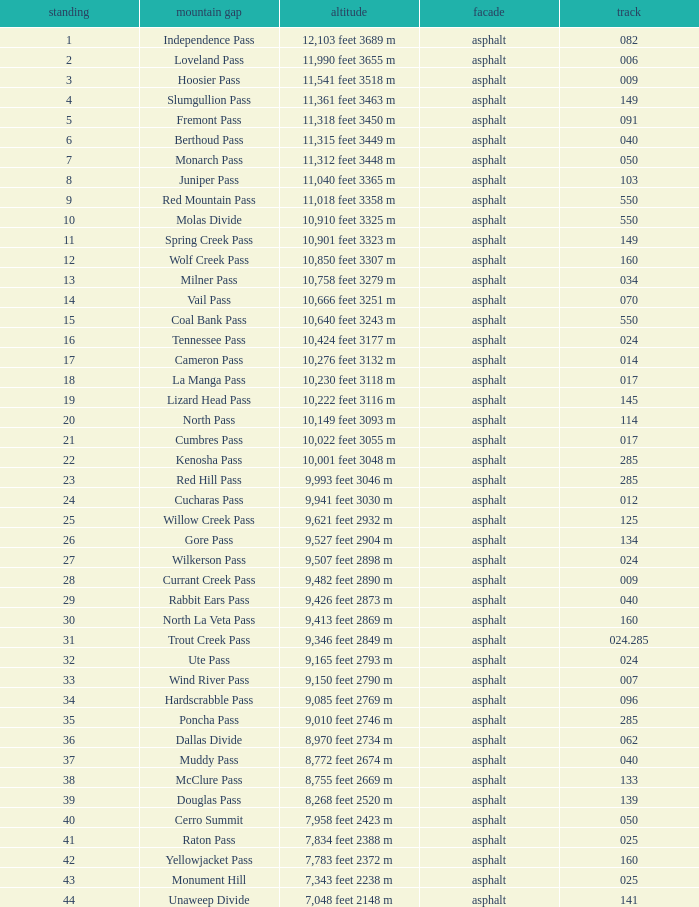Would you mind parsing the complete table? {'header': ['standing', 'mountain gap', 'altitude', 'facade', 'track'], 'rows': [['1', 'Independence Pass', '12,103 feet 3689 m', 'asphalt', '082'], ['2', 'Loveland Pass', '11,990 feet 3655 m', 'asphalt', '006'], ['3', 'Hoosier Pass', '11,541 feet 3518 m', 'asphalt', '009'], ['4', 'Slumgullion Pass', '11,361 feet 3463 m', 'asphalt', '149'], ['5', 'Fremont Pass', '11,318 feet 3450 m', 'asphalt', '091'], ['6', 'Berthoud Pass', '11,315 feet 3449 m', 'asphalt', '040'], ['7', 'Monarch Pass', '11,312 feet 3448 m', 'asphalt', '050'], ['8', 'Juniper Pass', '11,040 feet 3365 m', 'asphalt', '103'], ['9', 'Red Mountain Pass', '11,018 feet 3358 m', 'asphalt', '550'], ['10', 'Molas Divide', '10,910 feet 3325 m', 'asphalt', '550'], ['11', 'Spring Creek Pass', '10,901 feet 3323 m', 'asphalt', '149'], ['12', 'Wolf Creek Pass', '10,850 feet 3307 m', 'asphalt', '160'], ['13', 'Milner Pass', '10,758 feet 3279 m', 'asphalt', '034'], ['14', 'Vail Pass', '10,666 feet 3251 m', 'asphalt', '070'], ['15', 'Coal Bank Pass', '10,640 feet 3243 m', 'asphalt', '550'], ['16', 'Tennessee Pass', '10,424 feet 3177 m', 'asphalt', '024'], ['17', 'Cameron Pass', '10,276 feet 3132 m', 'asphalt', '014'], ['18', 'La Manga Pass', '10,230 feet 3118 m', 'asphalt', '017'], ['19', 'Lizard Head Pass', '10,222 feet 3116 m', 'asphalt', '145'], ['20', 'North Pass', '10,149 feet 3093 m', 'asphalt', '114'], ['21', 'Cumbres Pass', '10,022 feet 3055 m', 'asphalt', '017'], ['22', 'Kenosha Pass', '10,001 feet 3048 m', 'asphalt', '285'], ['23', 'Red Hill Pass', '9,993 feet 3046 m', 'asphalt', '285'], ['24', 'Cucharas Pass', '9,941 feet 3030 m', 'asphalt', '012'], ['25', 'Willow Creek Pass', '9,621 feet 2932 m', 'asphalt', '125'], ['26', 'Gore Pass', '9,527 feet 2904 m', 'asphalt', '134'], ['27', 'Wilkerson Pass', '9,507 feet 2898 m', 'asphalt', '024'], ['28', 'Currant Creek Pass', '9,482 feet 2890 m', 'asphalt', '009'], ['29', 'Rabbit Ears Pass', '9,426 feet 2873 m', 'asphalt', '040'], ['30', 'North La Veta Pass', '9,413 feet 2869 m', 'asphalt', '160'], ['31', 'Trout Creek Pass', '9,346 feet 2849 m', 'asphalt', '024.285'], ['32', 'Ute Pass', '9,165 feet 2793 m', 'asphalt', '024'], ['33', 'Wind River Pass', '9,150 feet 2790 m', 'asphalt', '007'], ['34', 'Hardscrabble Pass', '9,085 feet 2769 m', 'asphalt', '096'], ['35', 'Poncha Pass', '9,010 feet 2746 m', 'asphalt', '285'], ['36', 'Dallas Divide', '8,970 feet 2734 m', 'asphalt', '062'], ['37', 'Muddy Pass', '8,772 feet 2674 m', 'asphalt', '040'], ['38', 'McClure Pass', '8,755 feet 2669 m', 'asphalt', '133'], ['39', 'Douglas Pass', '8,268 feet 2520 m', 'asphalt', '139'], ['40', 'Cerro Summit', '7,958 feet 2423 m', 'asphalt', '050'], ['41', 'Raton Pass', '7,834 feet 2388 m', 'asphalt', '025'], ['42', 'Yellowjacket Pass', '7,783 feet 2372 m', 'asphalt', '160'], ['43', 'Monument Hill', '7,343 feet 2238 m', 'asphalt', '025'], ['44', 'Unaweep Divide', '7,048 feet 2148 m', 'asphalt', '141']]} What is the Mountain Pass with a 21 Rank? Cumbres Pass. 